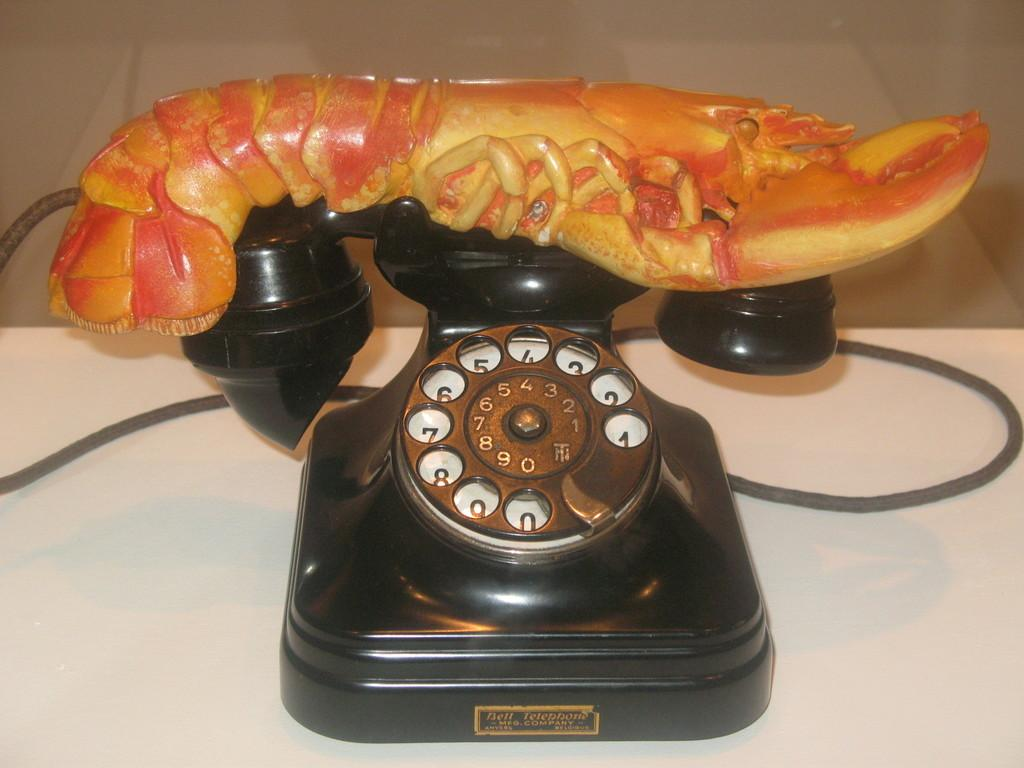What type of telephone is in the image? There is a black color telephone in the image. On what surface is the telephone placed? The telephone is placed on a white surface. What additional object can be seen on the telephone? There is a toy prawn on the telephone. How many kittens are playing on the level of respect in the image? There are no kittens or levels of respect present in the image. 